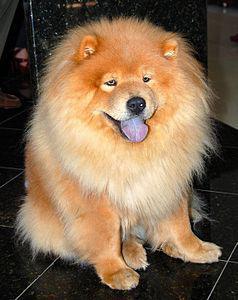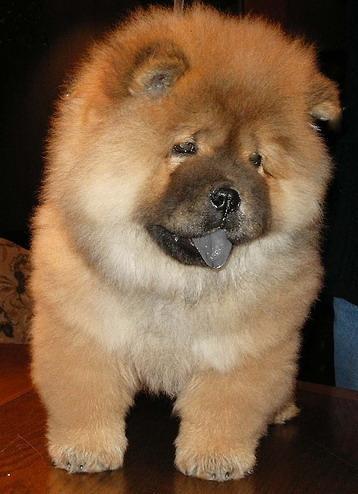The first image is the image on the left, the second image is the image on the right. For the images displayed, is the sentence "The right image shows a pale cream-colored chow pup standing on all fours." factually correct? Answer yes or no. No. 